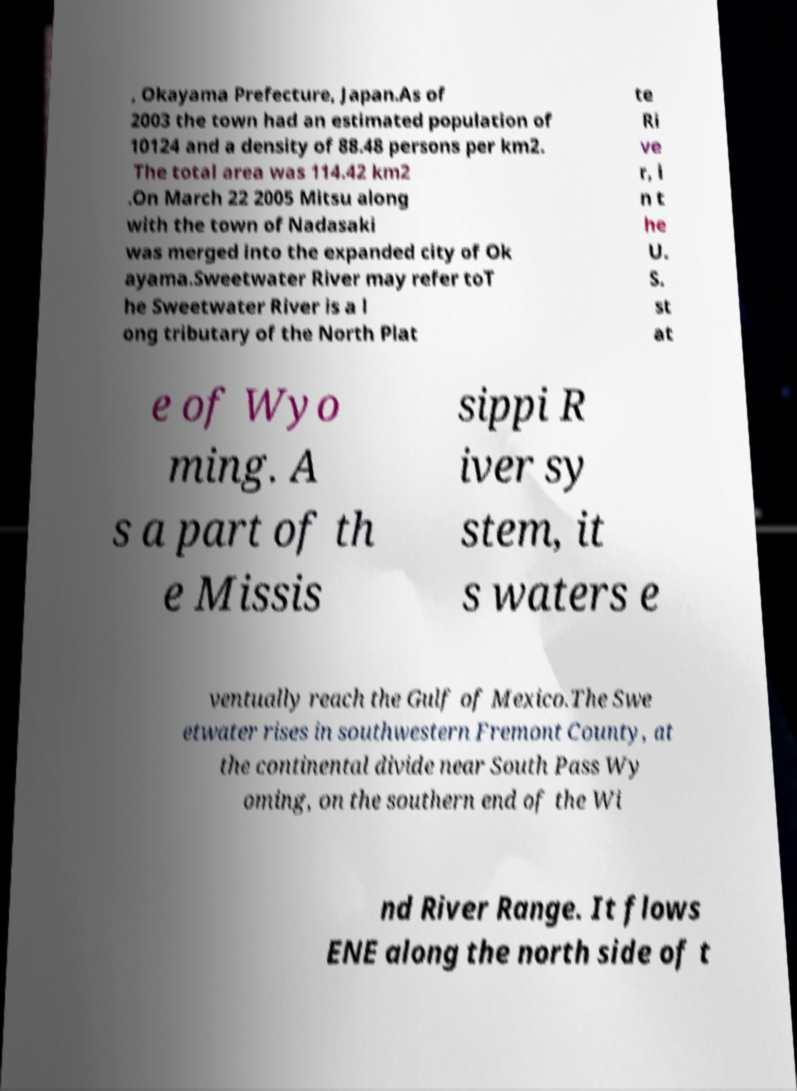Can you accurately transcribe the text from the provided image for me? , Okayama Prefecture, Japan.As of 2003 the town had an estimated population of 10124 and a density of 88.48 persons per km2. The total area was 114.42 km2 .On March 22 2005 Mitsu along with the town of Nadasaki was merged into the expanded city of Ok ayama.Sweetwater River may refer toT he Sweetwater River is a l ong tributary of the North Plat te Ri ve r, i n t he U. S. st at e of Wyo ming. A s a part of th e Missis sippi R iver sy stem, it s waters e ventually reach the Gulf of Mexico.The Swe etwater rises in southwestern Fremont County, at the continental divide near South Pass Wy oming, on the southern end of the Wi nd River Range. It flows ENE along the north side of t 